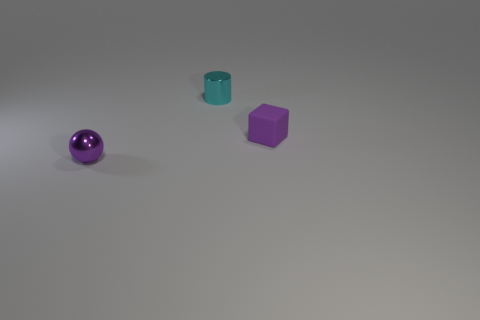Add 2 shiny cylinders. How many objects exist? 5 Subtract 0 gray cylinders. How many objects are left? 3 Subtract all balls. How many objects are left? 2 Subtract 1 spheres. How many spheres are left? 0 Subtract all yellow cubes. How many yellow balls are left? 0 Subtract all big yellow matte spheres. Subtract all cubes. How many objects are left? 2 Add 1 cyan cylinders. How many cyan cylinders are left? 2 Add 3 purple spheres. How many purple spheres exist? 4 